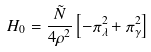Convert formula to latex. <formula><loc_0><loc_0><loc_500><loc_500>H _ { 0 } = \frac { \tilde { N } } { 4 \rho ^ { 2 } } \left [ - \pi _ { \lambda } ^ { 2 } + \pi _ { \gamma } ^ { 2 } \right ]</formula> 